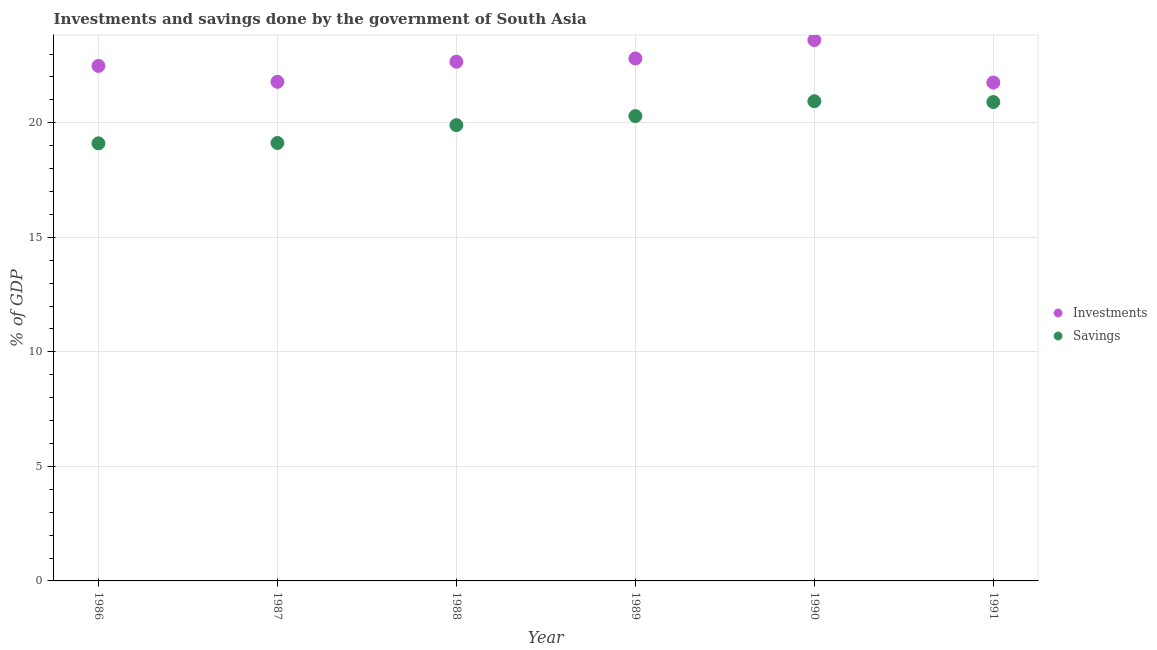How many different coloured dotlines are there?
Your response must be concise. 2. Is the number of dotlines equal to the number of legend labels?
Make the answer very short. Yes. What is the savings of government in 1987?
Offer a very short reply. 19.12. Across all years, what is the maximum savings of government?
Offer a terse response. 20.94. Across all years, what is the minimum savings of government?
Your response must be concise. 19.1. In which year was the savings of government maximum?
Keep it short and to the point. 1990. In which year was the investments of government minimum?
Your response must be concise. 1991. What is the total investments of government in the graph?
Ensure brevity in your answer.  135.1. What is the difference between the investments of government in 1988 and that in 1989?
Provide a short and direct response. -0.14. What is the difference between the savings of government in 1990 and the investments of government in 1986?
Ensure brevity in your answer.  -1.54. What is the average savings of government per year?
Provide a succinct answer. 20.04. In the year 1991, what is the difference between the investments of government and savings of government?
Your response must be concise. 0.85. In how many years, is the investments of government greater than 20 %?
Your answer should be compact. 6. What is the ratio of the savings of government in 1988 to that in 1989?
Provide a succinct answer. 0.98. Is the savings of government in 1987 less than that in 1989?
Offer a very short reply. Yes. What is the difference between the highest and the second highest savings of government?
Provide a succinct answer. 0.04. What is the difference between the highest and the lowest savings of government?
Give a very brief answer. 1.84. In how many years, is the savings of government greater than the average savings of government taken over all years?
Make the answer very short. 3. Is the sum of the savings of government in 1986 and 1989 greater than the maximum investments of government across all years?
Ensure brevity in your answer.  Yes. Is the investments of government strictly greater than the savings of government over the years?
Offer a very short reply. Yes. How many years are there in the graph?
Your answer should be compact. 6. Are the values on the major ticks of Y-axis written in scientific E-notation?
Provide a succinct answer. No. Does the graph contain grids?
Give a very brief answer. Yes. Where does the legend appear in the graph?
Provide a succinct answer. Center right. How are the legend labels stacked?
Your response must be concise. Vertical. What is the title of the graph?
Give a very brief answer. Investments and savings done by the government of South Asia. What is the label or title of the Y-axis?
Ensure brevity in your answer.  % of GDP. What is the % of GDP in Investments in 1986?
Your answer should be very brief. 22.48. What is the % of GDP in Savings in 1986?
Ensure brevity in your answer.  19.1. What is the % of GDP of Investments in 1987?
Give a very brief answer. 21.79. What is the % of GDP of Savings in 1987?
Make the answer very short. 19.12. What is the % of GDP of Investments in 1988?
Provide a succinct answer. 22.66. What is the % of GDP of Savings in 1988?
Your answer should be very brief. 19.9. What is the % of GDP in Investments in 1989?
Keep it short and to the point. 22.81. What is the % of GDP of Savings in 1989?
Ensure brevity in your answer.  20.29. What is the % of GDP in Investments in 1990?
Your answer should be compact. 23.61. What is the % of GDP of Savings in 1990?
Make the answer very short. 20.94. What is the % of GDP in Investments in 1991?
Your response must be concise. 21.75. What is the % of GDP in Savings in 1991?
Offer a very short reply. 20.9. Across all years, what is the maximum % of GDP of Investments?
Provide a succinct answer. 23.61. Across all years, what is the maximum % of GDP of Savings?
Give a very brief answer. 20.94. Across all years, what is the minimum % of GDP in Investments?
Your answer should be compact. 21.75. Across all years, what is the minimum % of GDP of Savings?
Provide a short and direct response. 19.1. What is the total % of GDP of Investments in the graph?
Offer a terse response. 135.1. What is the total % of GDP of Savings in the graph?
Your answer should be compact. 120.25. What is the difference between the % of GDP of Investments in 1986 and that in 1987?
Keep it short and to the point. 0.7. What is the difference between the % of GDP in Savings in 1986 and that in 1987?
Your response must be concise. -0.02. What is the difference between the % of GDP of Investments in 1986 and that in 1988?
Provide a short and direct response. -0.18. What is the difference between the % of GDP in Savings in 1986 and that in 1988?
Offer a terse response. -0.79. What is the difference between the % of GDP of Investments in 1986 and that in 1989?
Provide a succinct answer. -0.33. What is the difference between the % of GDP in Savings in 1986 and that in 1989?
Your response must be concise. -1.19. What is the difference between the % of GDP of Investments in 1986 and that in 1990?
Provide a succinct answer. -1.13. What is the difference between the % of GDP of Savings in 1986 and that in 1990?
Keep it short and to the point. -1.84. What is the difference between the % of GDP in Investments in 1986 and that in 1991?
Your answer should be very brief. 0.73. What is the difference between the % of GDP of Savings in 1986 and that in 1991?
Provide a succinct answer. -1.8. What is the difference between the % of GDP of Investments in 1987 and that in 1988?
Your answer should be compact. -0.88. What is the difference between the % of GDP of Savings in 1987 and that in 1988?
Make the answer very short. -0.78. What is the difference between the % of GDP of Investments in 1987 and that in 1989?
Your answer should be very brief. -1.02. What is the difference between the % of GDP in Savings in 1987 and that in 1989?
Ensure brevity in your answer.  -1.17. What is the difference between the % of GDP in Investments in 1987 and that in 1990?
Offer a terse response. -1.82. What is the difference between the % of GDP in Savings in 1987 and that in 1990?
Your response must be concise. -1.82. What is the difference between the % of GDP in Investments in 1987 and that in 1991?
Offer a terse response. 0.03. What is the difference between the % of GDP in Savings in 1987 and that in 1991?
Your answer should be very brief. -1.79. What is the difference between the % of GDP of Investments in 1988 and that in 1989?
Ensure brevity in your answer.  -0.14. What is the difference between the % of GDP of Savings in 1988 and that in 1989?
Offer a very short reply. -0.4. What is the difference between the % of GDP of Investments in 1988 and that in 1990?
Offer a very short reply. -0.95. What is the difference between the % of GDP in Savings in 1988 and that in 1990?
Your answer should be compact. -1.04. What is the difference between the % of GDP in Investments in 1988 and that in 1991?
Ensure brevity in your answer.  0.91. What is the difference between the % of GDP of Savings in 1988 and that in 1991?
Make the answer very short. -1.01. What is the difference between the % of GDP of Investments in 1989 and that in 1990?
Ensure brevity in your answer.  -0.8. What is the difference between the % of GDP of Savings in 1989 and that in 1990?
Give a very brief answer. -0.65. What is the difference between the % of GDP of Investments in 1989 and that in 1991?
Offer a terse response. 1.05. What is the difference between the % of GDP of Savings in 1989 and that in 1991?
Your answer should be very brief. -0.61. What is the difference between the % of GDP in Investments in 1990 and that in 1991?
Provide a short and direct response. 1.86. What is the difference between the % of GDP in Savings in 1990 and that in 1991?
Your response must be concise. 0.04. What is the difference between the % of GDP in Investments in 1986 and the % of GDP in Savings in 1987?
Ensure brevity in your answer.  3.36. What is the difference between the % of GDP of Investments in 1986 and the % of GDP of Savings in 1988?
Make the answer very short. 2.59. What is the difference between the % of GDP of Investments in 1986 and the % of GDP of Savings in 1989?
Make the answer very short. 2.19. What is the difference between the % of GDP in Investments in 1986 and the % of GDP in Savings in 1990?
Keep it short and to the point. 1.54. What is the difference between the % of GDP in Investments in 1986 and the % of GDP in Savings in 1991?
Your answer should be compact. 1.58. What is the difference between the % of GDP of Investments in 1987 and the % of GDP of Savings in 1988?
Your answer should be very brief. 1.89. What is the difference between the % of GDP of Investments in 1987 and the % of GDP of Savings in 1989?
Your answer should be very brief. 1.49. What is the difference between the % of GDP in Investments in 1987 and the % of GDP in Savings in 1990?
Make the answer very short. 0.85. What is the difference between the % of GDP in Investments in 1987 and the % of GDP in Savings in 1991?
Offer a terse response. 0.88. What is the difference between the % of GDP in Investments in 1988 and the % of GDP in Savings in 1989?
Ensure brevity in your answer.  2.37. What is the difference between the % of GDP of Investments in 1988 and the % of GDP of Savings in 1990?
Your answer should be very brief. 1.73. What is the difference between the % of GDP in Investments in 1988 and the % of GDP in Savings in 1991?
Offer a very short reply. 1.76. What is the difference between the % of GDP in Investments in 1989 and the % of GDP in Savings in 1990?
Give a very brief answer. 1.87. What is the difference between the % of GDP in Investments in 1989 and the % of GDP in Savings in 1991?
Ensure brevity in your answer.  1.9. What is the difference between the % of GDP of Investments in 1990 and the % of GDP of Savings in 1991?
Give a very brief answer. 2.71. What is the average % of GDP in Investments per year?
Ensure brevity in your answer.  22.52. What is the average % of GDP of Savings per year?
Your answer should be very brief. 20.04. In the year 1986, what is the difference between the % of GDP in Investments and % of GDP in Savings?
Your response must be concise. 3.38. In the year 1987, what is the difference between the % of GDP in Investments and % of GDP in Savings?
Provide a succinct answer. 2.67. In the year 1988, what is the difference between the % of GDP of Investments and % of GDP of Savings?
Make the answer very short. 2.77. In the year 1989, what is the difference between the % of GDP of Investments and % of GDP of Savings?
Your response must be concise. 2.52. In the year 1990, what is the difference between the % of GDP in Investments and % of GDP in Savings?
Ensure brevity in your answer.  2.67. In the year 1991, what is the difference between the % of GDP of Investments and % of GDP of Savings?
Provide a short and direct response. 0.85. What is the ratio of the % of GDP in Investments in 1986 to that in 1987?
Your answer should be very brief. 1.03. What is the ratio of the % of GDP in Savings in 1986 to that in 1987?
Provide a succinct answer. 1. What is the ratio of the % of GDP of Savings in 1986 to that in 1988?
Give a very brief answer. 0.96. What is the ratio of the % of GDP in Investments in 1986 to that in 1989?
Your answer should be compact. 0.99. What is the ratio of the % of GDP in Savings in 1986 to that in 1989?
Your answer should be compact. 0.94. What is the ratio of the % of GDP in Investments in 1986 to that in 1990?
Your answer should be very brief. 0.95. What is the ratio of the % of GDP of Savings in 1986 to that in 1990?
Keep it short and to the point. 0.91. What is the ratio of the % of GDP in Investments in 1986 to that in 1991?
Provide a succinct answer. 1.03. What is the ratio of the % of GDP of Savings in 1986 to that in 1991?
Your answer should be compact. 0.91. What is the ratio of the % of GDP in Investments in 1987 to that in 1988?
Your response must be concise. 0.96. What is the ratio of the % of GDP of Savings in 1987 to that in 1988?
Make the answer very short. 0.96. What is the ratio of the % of GDP in Investments in 1987 to that in 1989?
Offer a terse response. 0.96. What is the ratio of the % of GDP of Savings in 1987 to that in 1989?
Provide a short and direct response. 0.94. What is the ratio of the % of GDP of Investments in 1987 to that in 1990?
Ensure brevity in your answer.  0.92. What is the ratio of the % of GDP of Savings in 1987 to that in 1991?
Provide a succinct answer. 0.91. What is the ratio of the % of GDP of Investments in 1988 to that in 1989?
Keep it short and to the point. 0.99. What is the ratio of the % of GDP of Savings in 1988 to that in 1989?
Offer a very short reply. 0.98. What is the ratio of the % of GDP of Investments in 1988 to that in 1990?
Make the answer very short. 0.96. What is the ratio of the % of GDP of Savings in 1988 to that in 1990?
Your answer should be very brief. 0.95. What is the ratio of the % of GDP in Investments in 1988 to that in 1991?
Your response must be concise. 1.04. What is the ratio of the % of GDP in Savings in 1988 to that in 1991?
Give a very brief answer. 0.95. What is the ratio of the % of GDP in Savings in 1989 to that in 1990?
Provide a short and direct response. 0.97. What is the ratio of the % of GDP in Investments in 1989 to that in 1991?
Give a very brief answer. 1.05. What is the ratio of the % of GDP in Savings in 1989 to that in 1991?
Offer a terse response. 0.97. What is the ratio of the % of GDP of Investments in 1990 to that in 1991?
Your answer should be very brief. 1.09. What is the difference between the highest and the second highest % of GDP of Investments?
Offer a very short reply. 0.8. What is the difference between the highest and the second highest % of GDP of Savings?
Offer a very short reply. 0.04. What is the difference between the highest and the lowest % of GDP of Investments?
Offer a terse response. 1.86. What is the difference between the highest and the lowest % of GDP of Savings?
Your answer should be very brief. 1.84. 